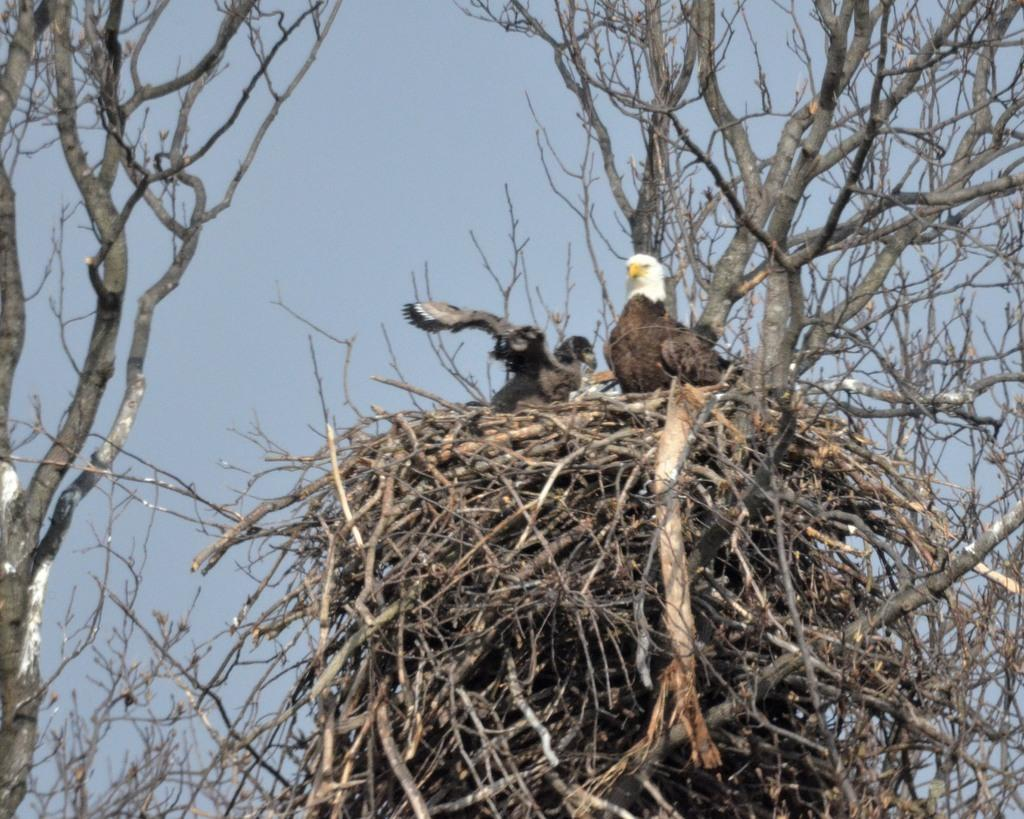What is located on the tree in the image? There is a bird nest on a nest on a tree in the image. How many birds can be seen in the image? There are two birds in the image. What colors are the birds in the image? The birds are brown, white, yellow, and black in color. What can be seen in the background of the image? The sky is visible in the background of the image. What type of organization is responsible for the blood donation event in the image? There is no blood donation event or organization present in the image; it features a bird nest and two birds. 